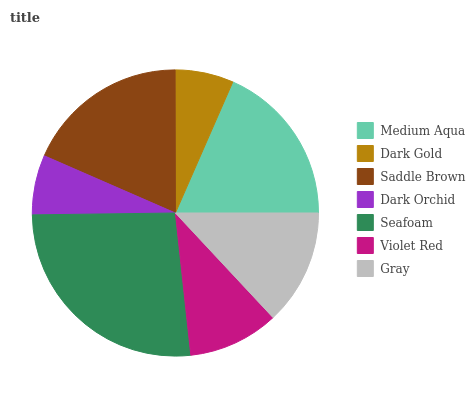Is Dark Gold the minimum?
Answer yes or no. Yes. Is Seafoam the maximum?
Answer yes or no. Yes. Is Saddle Brown the minimum?
Answer yes or no. No. Is Saddle Brown the maximum?
Answer yes or no. No. Is Saddle Brown greater than Dark Gold?
Answer yes or no. Yes. Is Dark Gold less than Saddle Brown?
Answer yes or no. Yes. Is Dark Gold greater than Saddle Brown?
Answer yes or no. No. Is Saddle Brown less than Dark Gold?
Answer yes or no. No. Is Gray the high median?
Answer yes or no. Yes. Is Gray the low median?
Answer yes or no. Yes. Is Medium Aqua the high median?
Answer yes or no. No. Is Seafoam the low median?
Answer yes or no. No. 